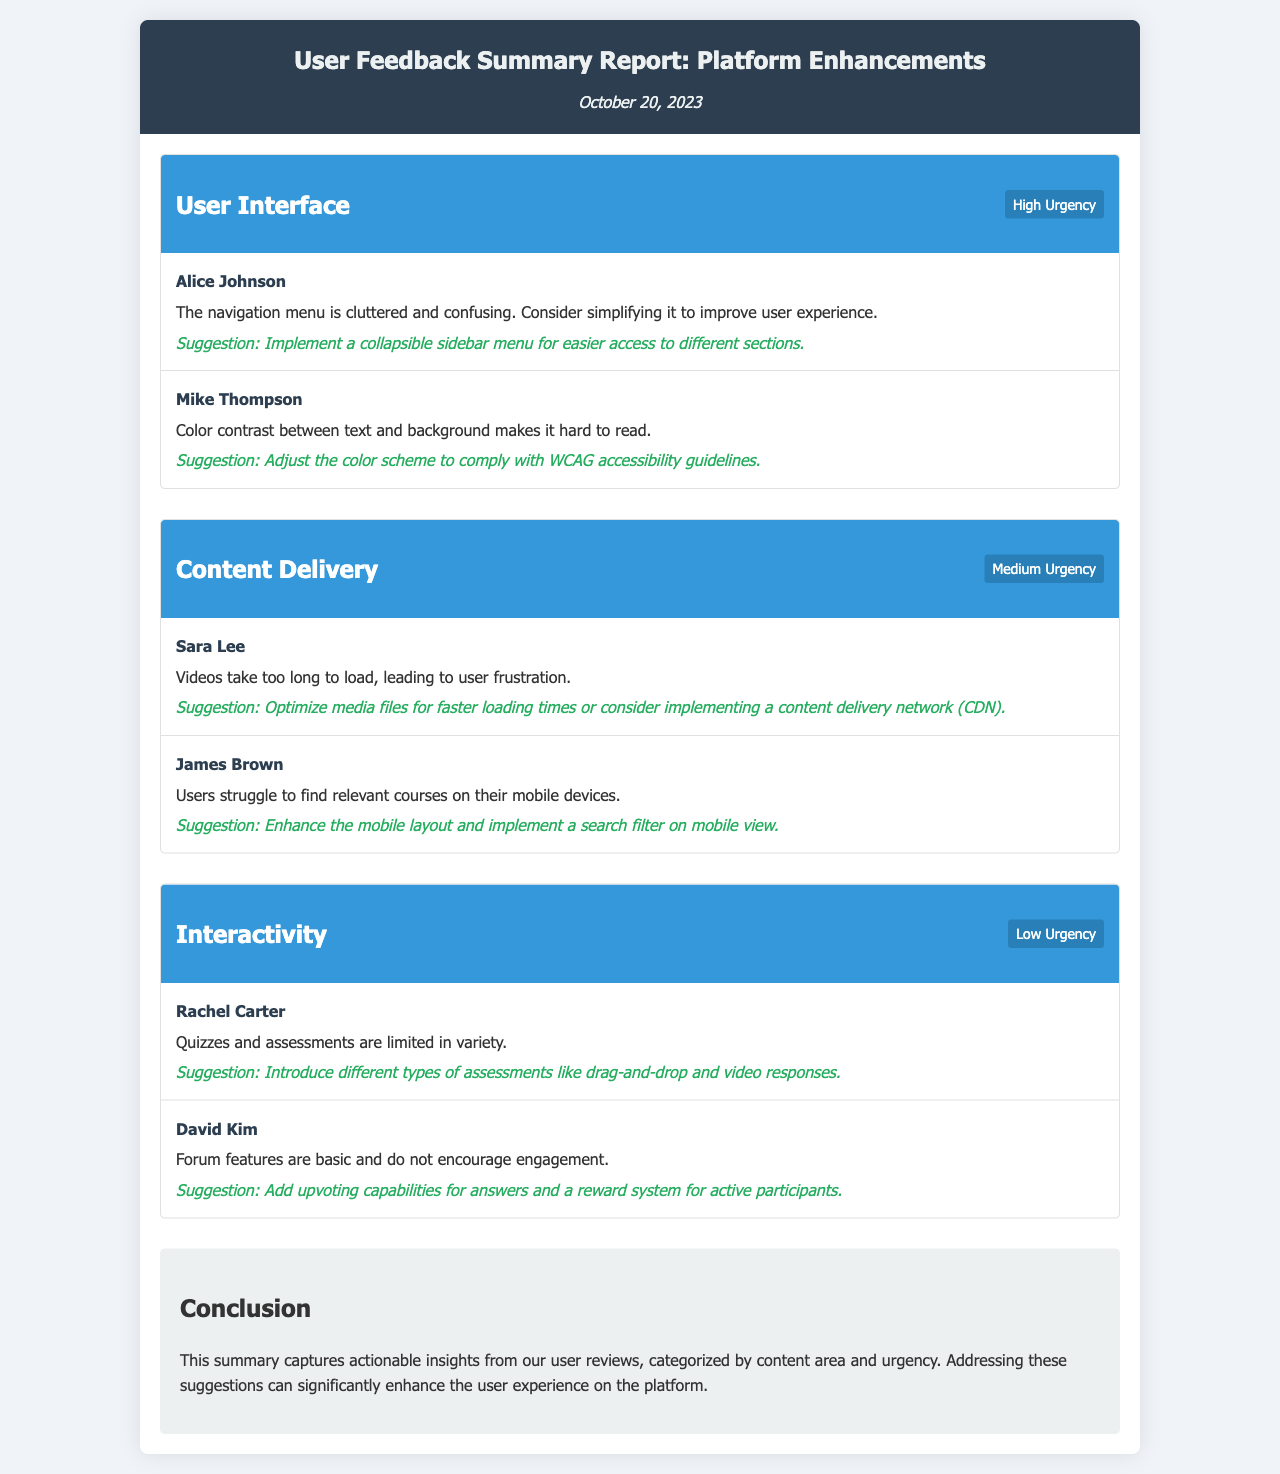What is the date of the report? The report date is mentioned at the top of the document, indicating when the feedback summary was compiled.
Answer: October 20, 2023 How many categories are there in the report? The report lists three distinct categories that organize the user feedback.
Answer: Three Who provided feedback on navigation menu issues? This information points to which user specifically expressed concerns about the user interface.
Answer: Alice Johnson What urgency level is associated with Content Delivery? The urgency level indicates how critical feedback regarding Content Delivery is, allowing prioritization of enhancements.
Answer: Medium Urgency What suggestion was made to improve video loading times? This question refers to the feedback provided about optimizing media files for a better user experience.
Answer: Optimize media files for faster loading times or consider implementing a content delivery network (CDN) Who mentioned that quizzes are limited in variety? This identifies the reviewer who highlighted a specific limitation regarding interactivity.
Answer: Rachel Carter What is the primary focus of the conclusion section? The conclusion summarizes the overall insights drawn from the user reviews.
Answer: Actionable insights from user reviews What type of question is suggested to encourage forum engagement? The suggested feature aims to enhance user participation in forum discussions, indicating a need for interactive elements.
Answer: Upvoting capabilities for answers and a reward system for active participants 